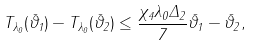<formula> <loc_0><loc_0><loc_500><loc_500>\| T _ { \lambda _ { 0 } } ( \bar { \vartheta } _ { 1 } ) - T _ { \lambda _ { 0 } } ( \bar { \vartheta } _ { 2 } ) \| \leq \frac { \chi _ { 4 } \lambda _ { 0 } \Delta _ { 2 } } { 7 } \| \bar { \vartheta } _ { 1 } - \bar { \vartheta } _ { 2 } \| ,</formula> 